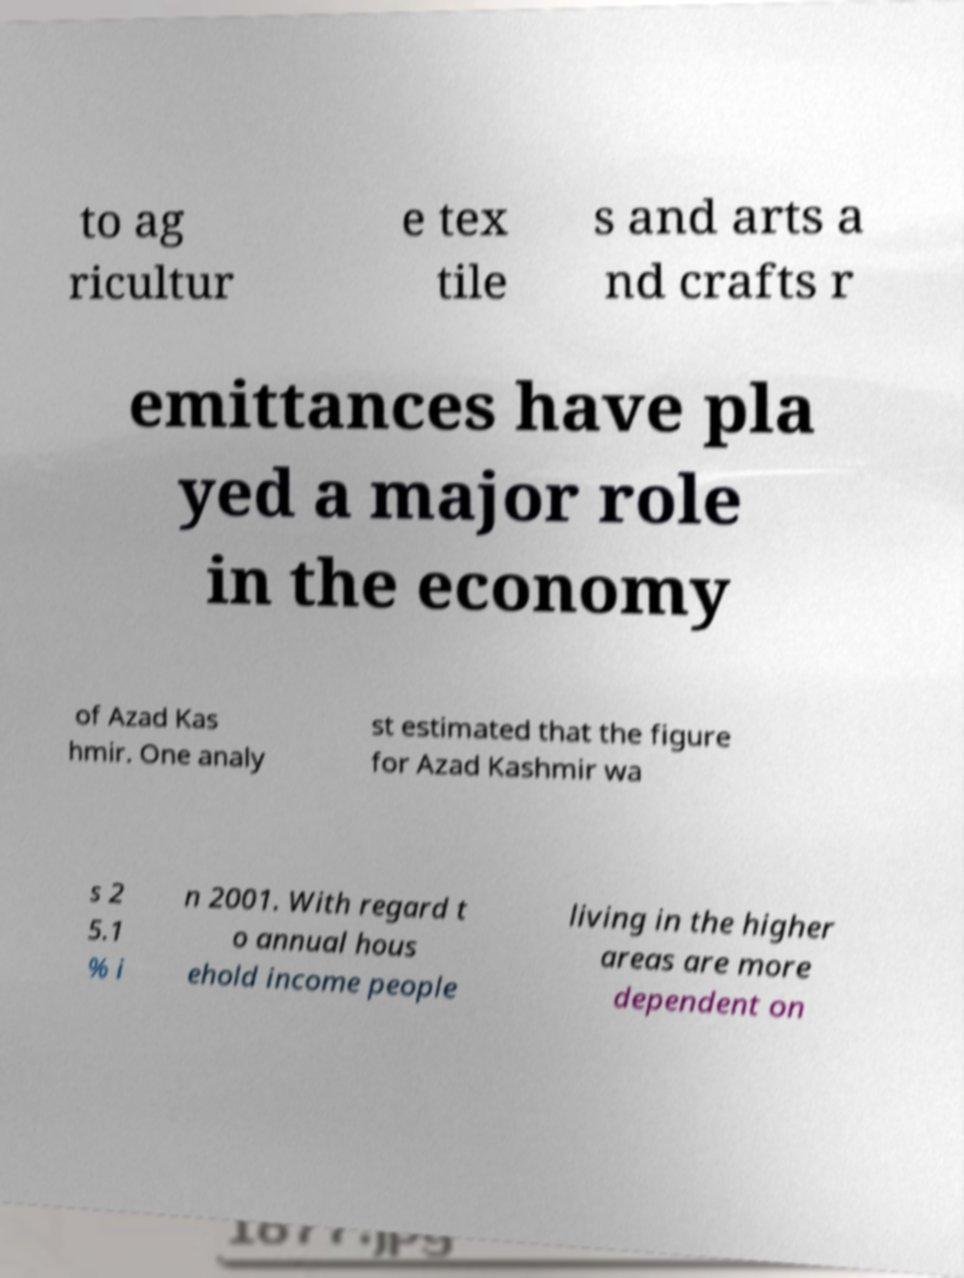There's text embedded in this image that I need extracted. Can you transcribe it verbatim? to ag ricultur e tex tile s and arts a nd crafts r emittances have pla yed a major role in the economy of Azad Kas hmir. One analy st estimated that the figure for Azad Kashmir wa s 2 5.1 % i n 2001. With regard t o annual hous ehold income people living in the higher areas are more dependent on 